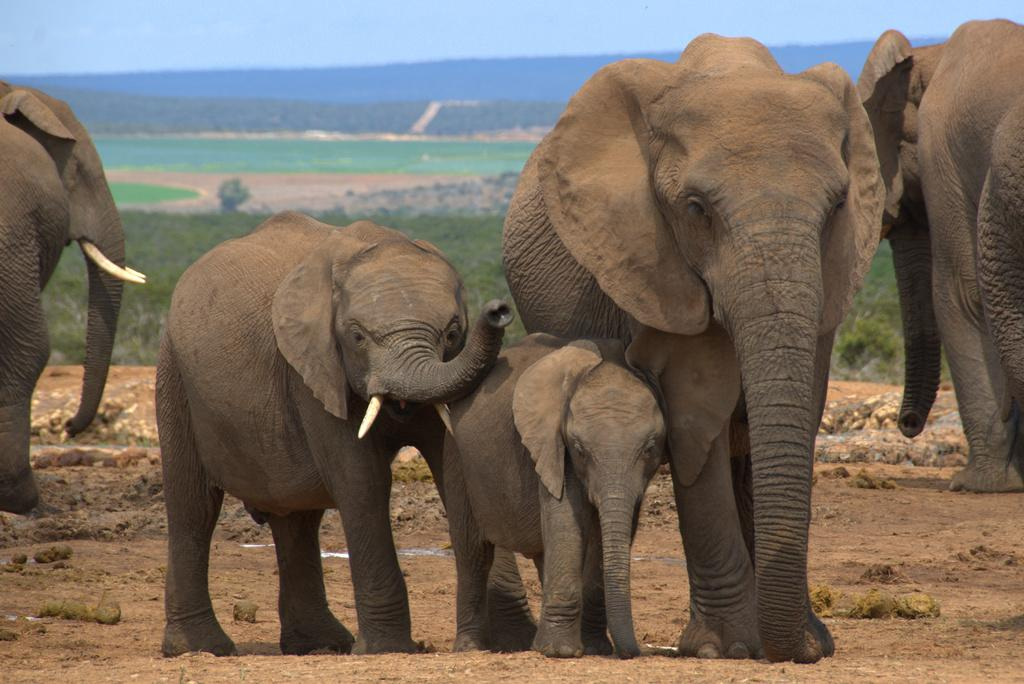What type of view is shown in the image? The image is an outside view. What animals can be seen on the ground in the image? There are elephants on the ground in the image. What can be seen in the background of the image? There is a field and a hill in the background of the image. What is visible at the top of the image? The sky is visible at the top of the image. Where is the toad hiding in the image? There is no toad present in the image. What type of sack is being carried by the elephants in the image? There are no sacks being carried by the elephants in the image. 